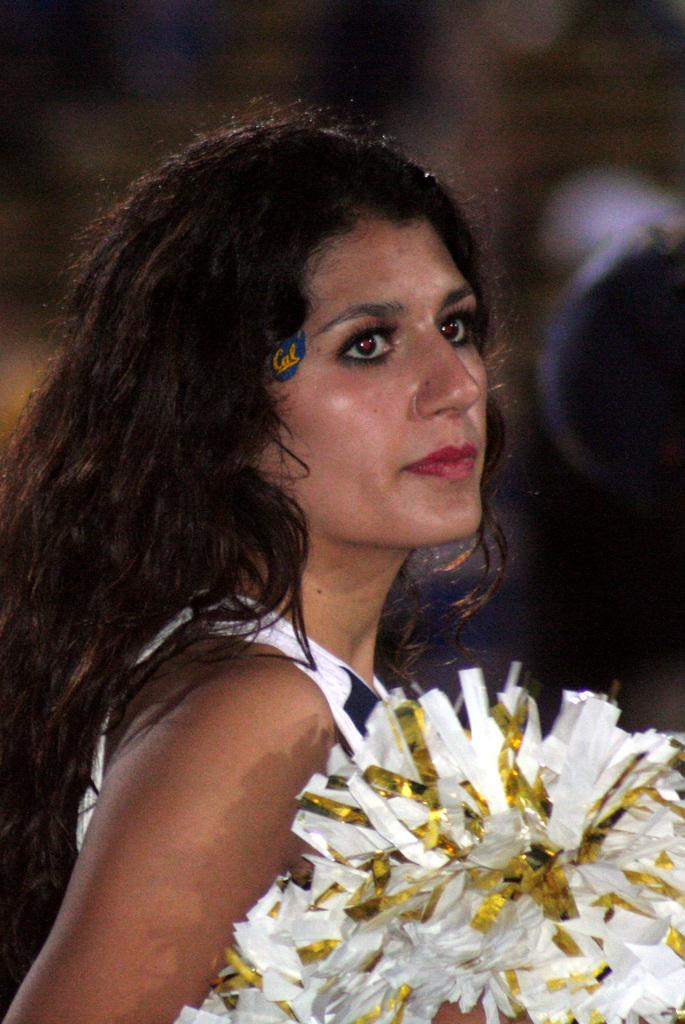What is the main subject of the image? There is a woman standing in the image. What is the woman holding in the image? The woman appears to be holding cheerleader pom poms. Can you describe the background of the image? The background of the image is blurry. What type of animal can be seen in the background of the image? There are no animals visible in the image, as the background is blurry. What song is the woman singing in the image? There is no indication in the image that the woman is singing, so it cannot be determined from the picture. 